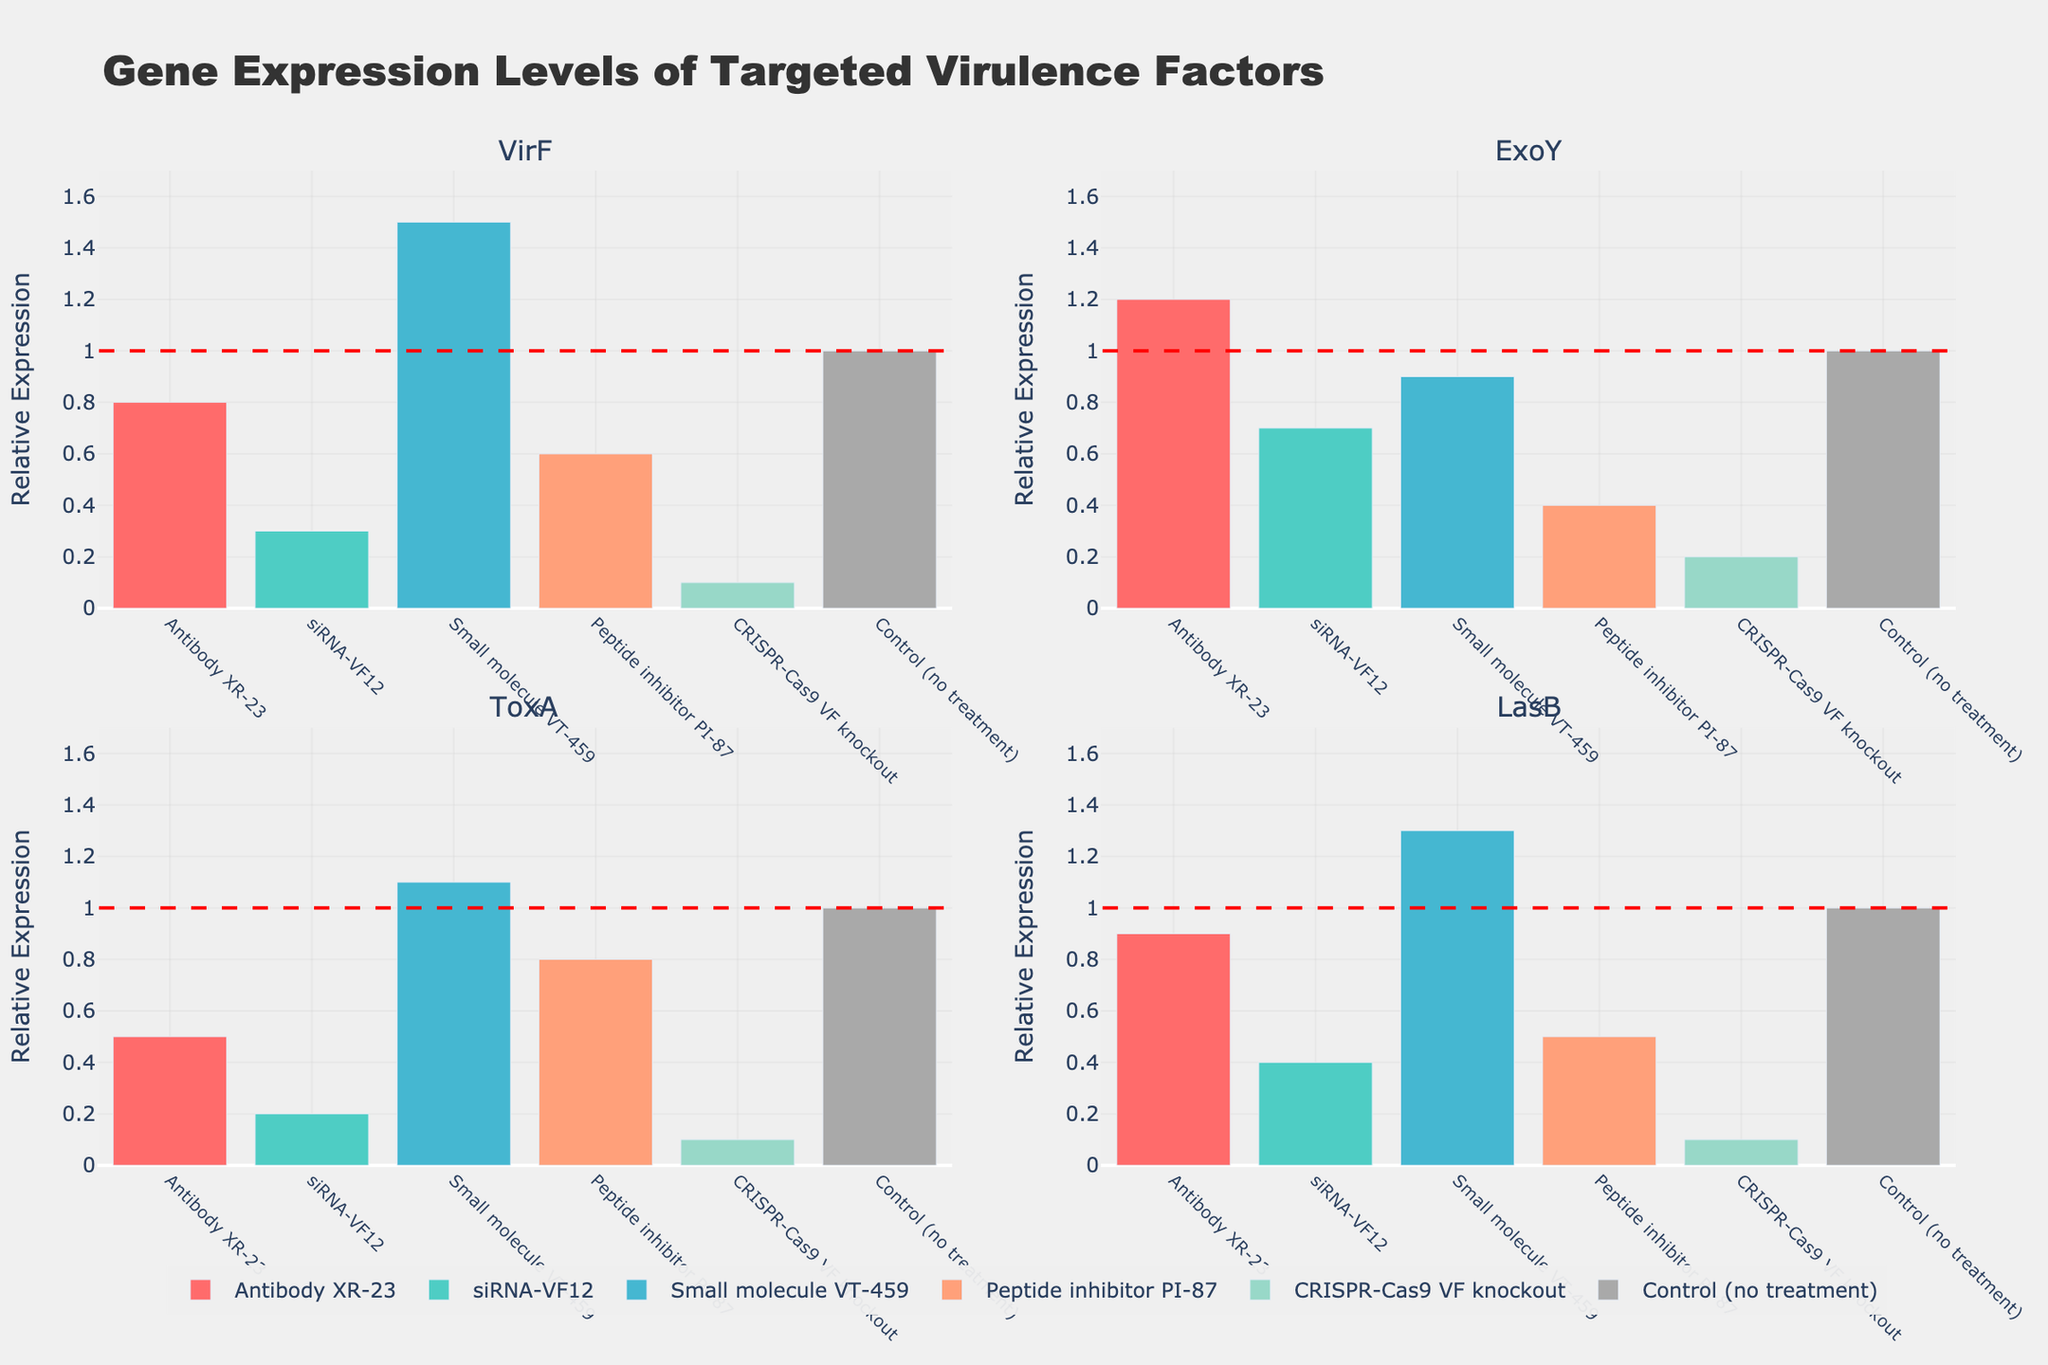Which therapy has the highest expression level for VirF? From the subplot 'VirF', observe the bar heights for each therapy. The highest bar corresponds to 'Small molecule VT-459' with a value of 1.5.
Answer: Small molecule VT-459 What is the expression level of ExoY for siRNA-VF12? In the 'ExoY' subplot, locate the bar corresponding to 'siRNA-VF12'. The height of this bar represents the expression level, which is 0.7.
Answer: 0.7 How does the LasB expression level for Antibody XR-23 compare to the control? Look at the 'LasB' subplot and compare the bar for 'Antibody XR-23' (0.9) to the control line which is set at 1.0. It's slightly lower than the control.
Answer: Slightly lower Which therapy shows the lowest expression levels across all virulence factors? For each subplot, identify the lowest bars and check which therapy they correspond to. 'CRISPR-Cas9 VF knockout' has the lowest bars across all four subplots (0.1 for VirF, 0.2 for ExoY, 0.1 for ToxA, 0.1 for LasB).
Answer: CRISPR-Cas9 VF knockout Calculate the average expression level of ToxA across all therapies. Sum the ToxA values for all therapies: 0.5 (Antibody XR-23) + 0.2 (siRNA-VF12) + 1.1 (Small molecule VT-459) + 0.8 (Peptide inhibitor PI-87) + 0.1 (CRISPR-Cas9 VF knockout) + 1.0 (Control). The total is 3.7. Divide by the number of therapies (6): 3.7 / 6 = 0.617.
Answer: 0.617 Which two therapies have the closest expression levels for ExoY? In the 'ExoY' subplot, compare the bars for each therapy. The two closest ones are 'siRNA-VF12' and 'Peptide inhibitor PI-87' with values 0.7 and 0.4 respectively. The difference is 0.3.
Answer: siRNA-VF12 and Peptide inhibitor PI-87 Determine the range of expression levels for VirF. Identify the smallest and largest values for VirF: The smallest is 0.1 (CRISPR-Cas9 VF knockout) and the largest is 1.5 (Small molecule VT-459). The range is 1.5 - 0.1 = 1.4.
Answer: 1.4 Is there any therapy where the expression level of one virulence factor matches the control? Observe each subplot and check for bars that are equal to the control line (value of 1). In 'ExoY', 'Control (no treatment)' itself matches the control.
Answer: Yes, Control (no treatment) in ExoY 